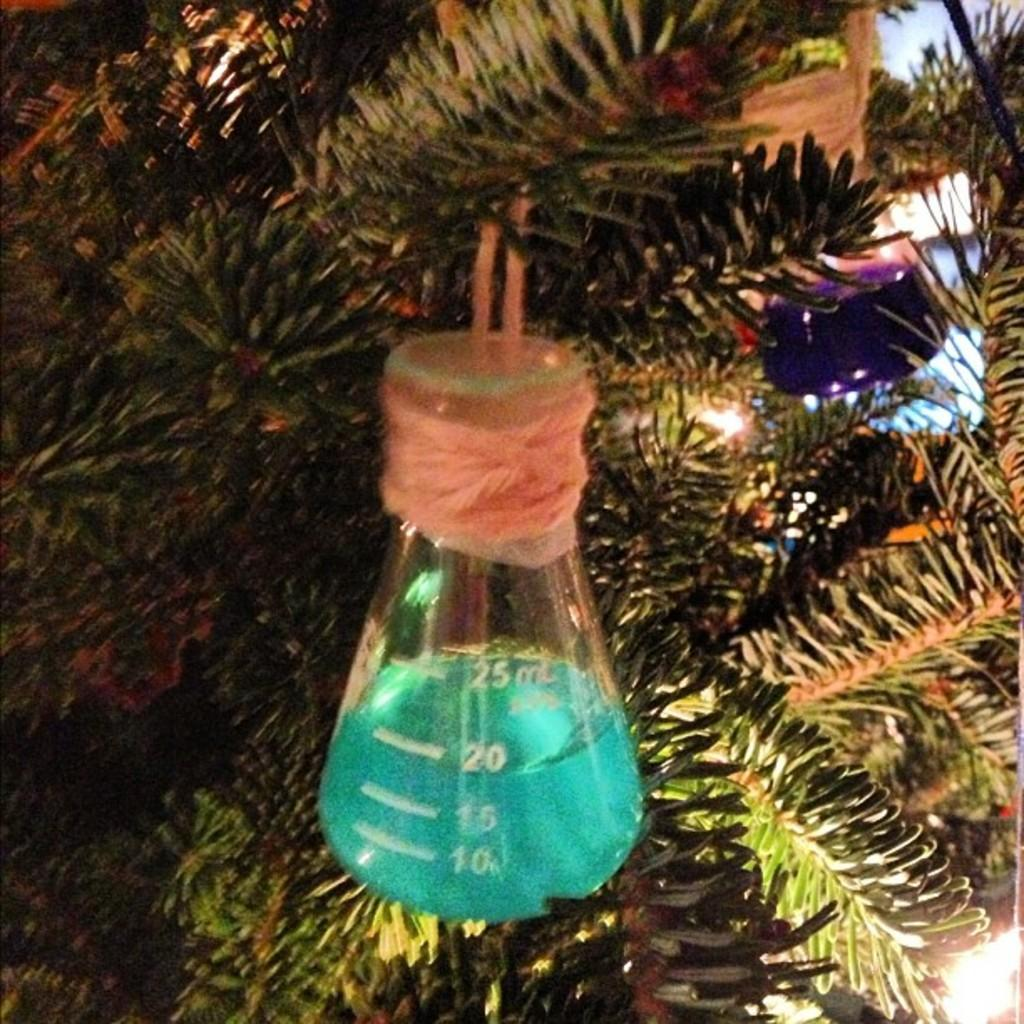What is the main object in the picture? There is a tree in the picture. What is hanging on the tree? Measuring jars are hung on the tree. Where are the measuring jars located in the picture? The measuring jars are located in the center and on the right side of the picture. What type of bone is visible in the picture? There is no bone present in the picture; it features a tree with measuring jars hanging on it. 